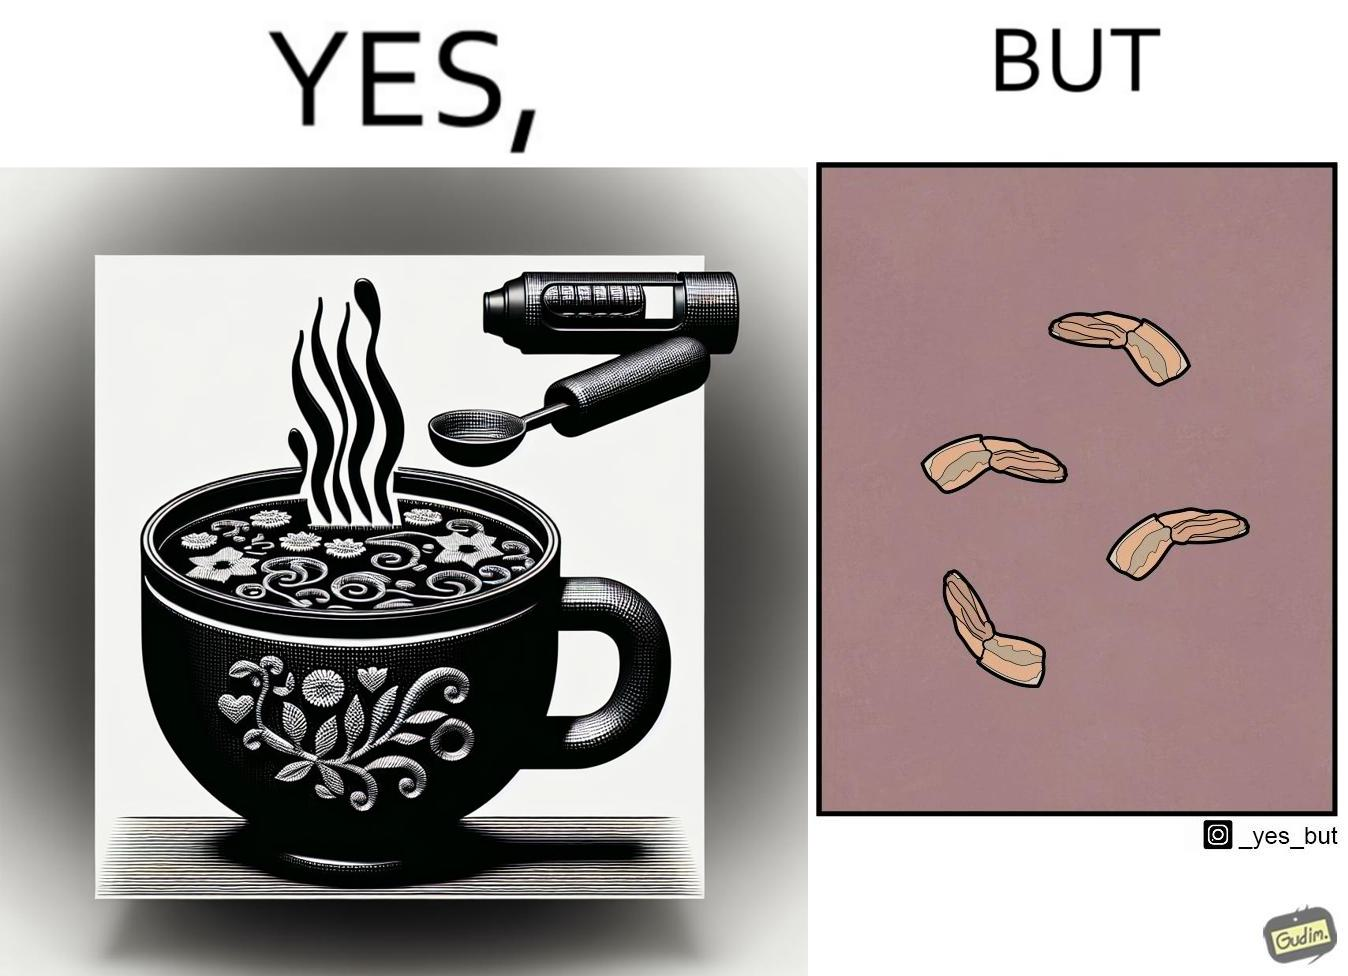Is this a satirical image? Yes, this image is satirical. 